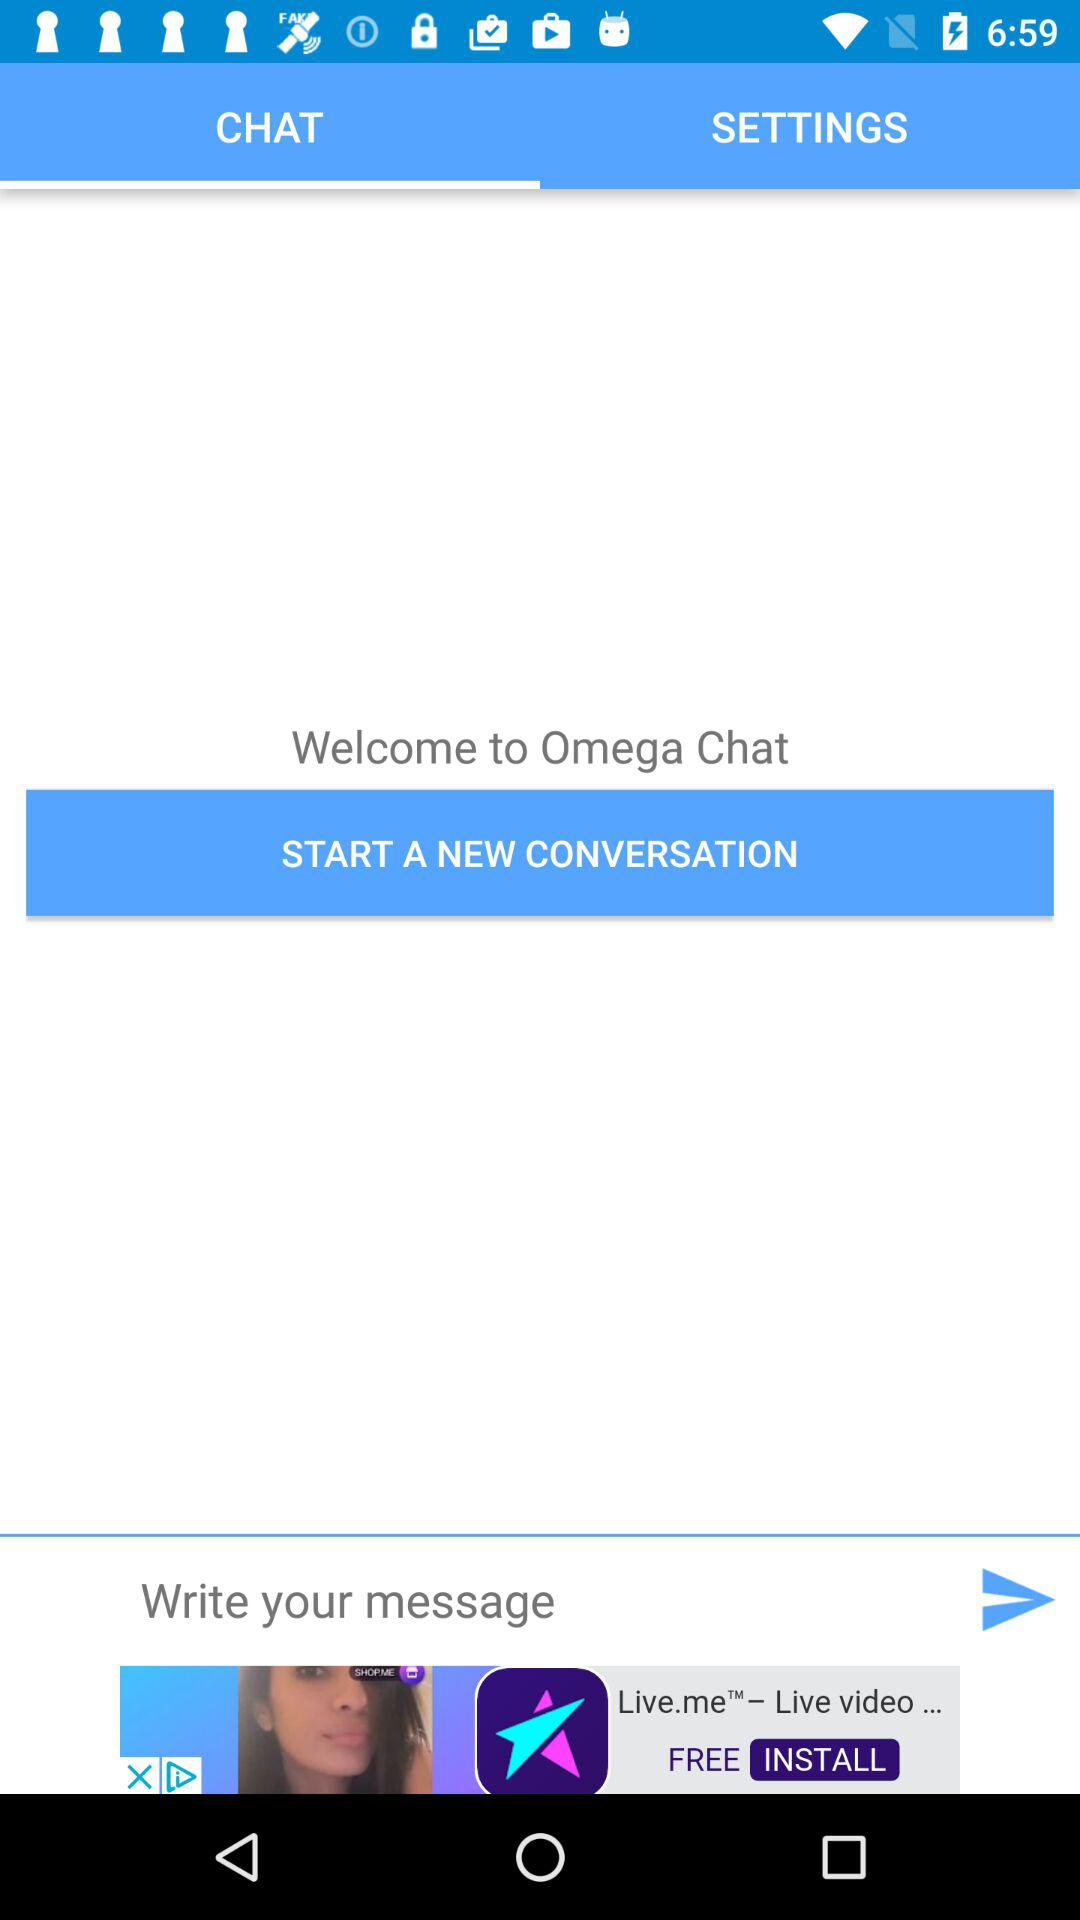What is the application name? The name of the application is "Omega Chat". 